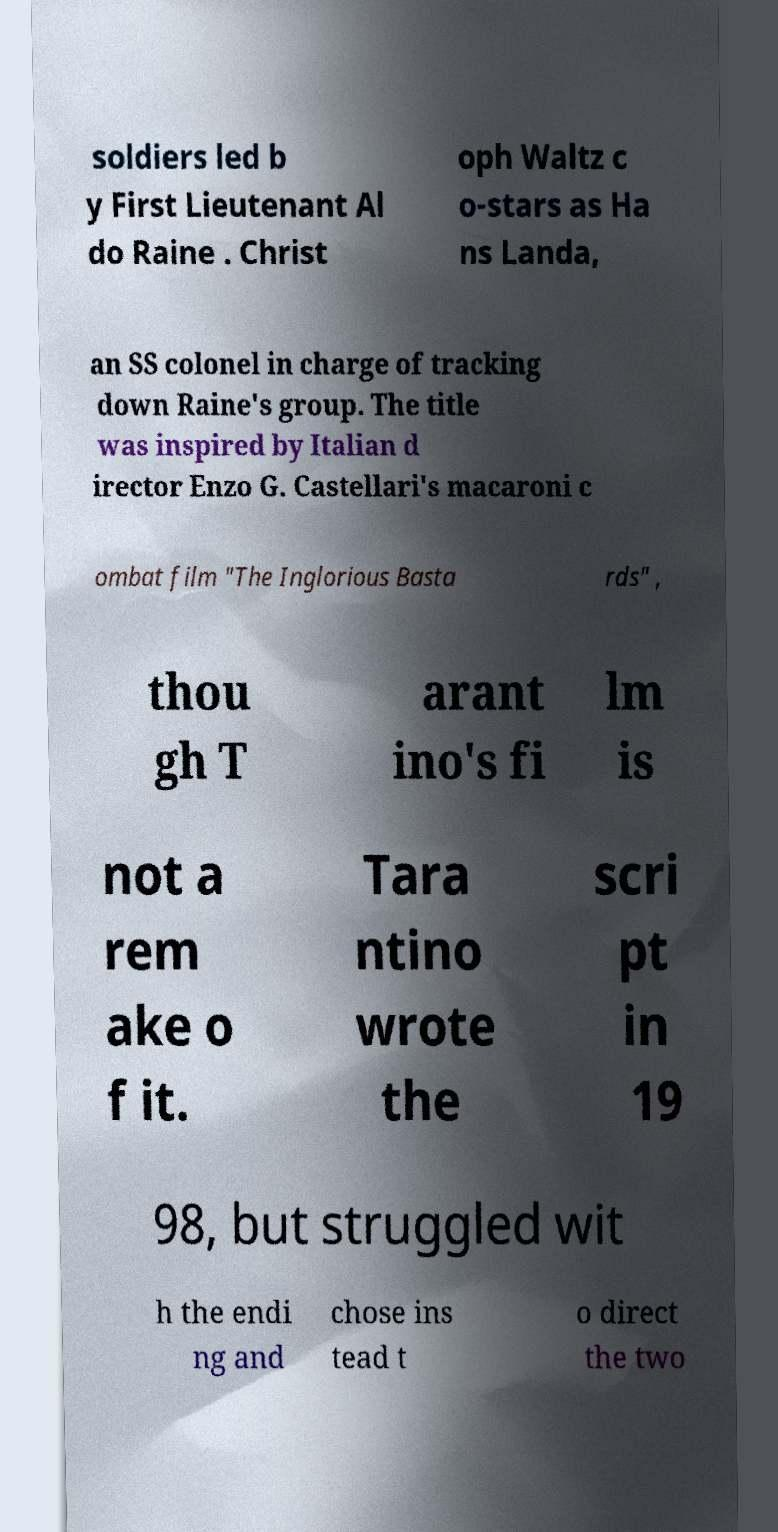I need the written content from this picture converted into text. Can you do that? soldiers led b y First Lieutenant Al do Raine . Christ oph Waltz c o-stars as Ha ns Landa, an SS colonel in charge of tracking down Raine's group. The title was inspired by Italian d irector Enzo G. Castellari's macaroni c ombat film "The Inglorious Basta rds" , thou gh T arant ino's fi lm is not a rem ake o f it. Tara ntino wrote the scri pt in 19 98, but struggled wit h the endi ng and chose ins tead t o direct the two 